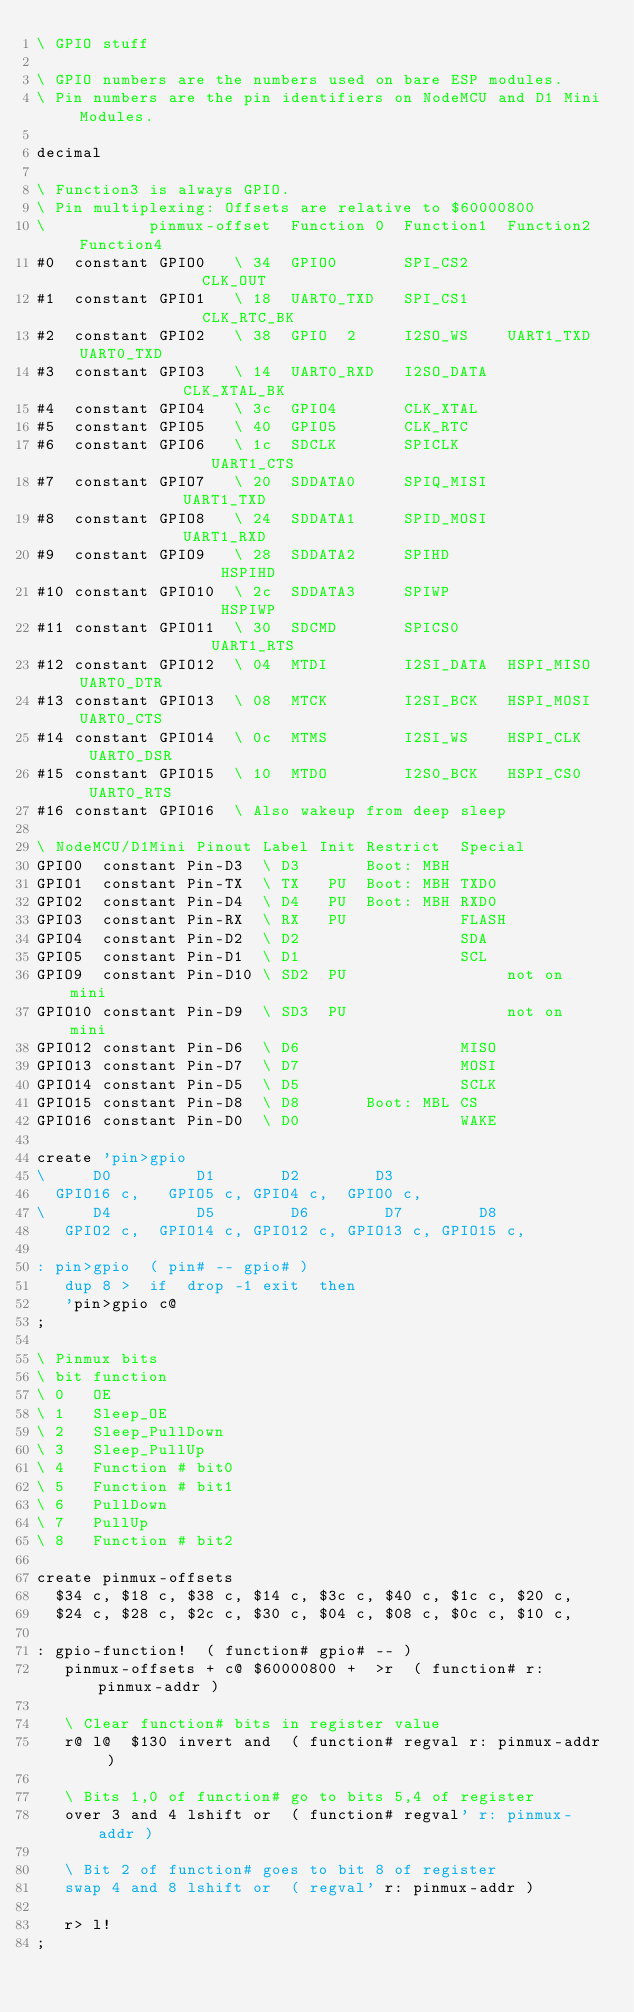<code> <loc_0><loc_0><loc_500><loc_500><_Forth_>\ GPIO stuff

\ GPIO numbers are the numbers used on bare ESP modules.
\ Pin numbers are the pin identifiers on NodeMCU and D1 Mini Modules.

decimal

\ Function3 is always GPIO.
\ Pin multiplexing: Offsets are relative to $60000800
\           pinmux-offset  Function 0  Function1  Function2  Function4
#0  constant GPIO0   \ 34  GPIO0       SPI_CS2               CLK_OUT
#1  constant GPIO1   \ 18  UART0_TXD   SPI_CS1               CLK_RTC_BK
#2  constant GPIO2   \ 38  GPIO  2     I2SO_WS    UART1_TXD  UART0_TXD
#3  constant GPIO3   \ 14  UART0_RXD   I2SO_DATA             CLK_XTAL_BK
#4  constant GPIO4   \ 3c  GPIO4       CLK_XTAL
#5  constant GPIO5   \ 40  GPIO5       CLK_RTC
#6  constant GPIO6   \ 1c  SDCLK       SPICLK                UART1_CTS
#7  constant GPIO7   \ 20  SDDATA0     SPIQ_MISI             UART1_TXD
#8  constant GPIO8   \ 24  SDDATA1     SPID_MOSI             UART1_RXD
#9  constant GPIO9   \ 28  SDDATA2     SPIHD                 HSPIHD
#10 constant GPIO10  \ 2c  SDDATA3     SPIWP                 HSPIWP
#11 constant GPIO11  \ 30  SDCMD       SPICS0                UART1_RTS
#12 constant GPIO12  \ 04  MTDI        I2SI_DATA  HSPI_MISO  UART0_DTR
#13 constant GPIO13  \ 08  MTCK        I2SI_BCK   HSPI_MOSI  UART0_CTS
#14 constant GPIO14  \ 0c  MTMS        I2SI_WS    HSPI_CLK   UART0_DSR
#15 constant GPIO15  \ 10  MTDO        I2S0_BCK   HSPI_CS0   UART0_RTS
#16 constant GPIO16  \ Also wakeup from deep sleep

\ NodeMCU/D1Mini Pinout Label Init Restrict  Special
GPIO0  constant Pin-D3  \ D3       Boot: MBH
GPIO1  constant Pin-TX  \ TX   PU  Boot: MBH TXD0
GPIO2  constant Pin-D4  \ D4   PU  Boot: MBH RXD0
GPIO3  constant Pin-RX  \ RX   PU            FLASH
GPIO4  constant Pin-D2  \ D2                 SDA
GPIO5  constant Pin-D1  \ D1                 SCL
GPIO9  constant Pin-D10 \ SD2  PU                 not on mini
GPIO10 constant Pin-D9  \ SD3  PU                 not on mini
GPIO12 constant Pin-D6  \ D6                 MISO
GPIO13 constant Pin-D7  \ D7                 MOSI
GPIO14 constant Pin-D5  \ D5                 SCLK
GPIO15 constant Pin-D8  \ D8       Boot: MBL CS
GPIO16 constant Pin-D0  \ D0                 WAKE

create 'pin>gpio
\     D0         D1       D2        D3   
  GPIO16 c,   GPIO5 c, GPIO4 c,  GPIO0 c,
\     D4         D5        D6        D7        D8      
   GPIO2 c,  GPIO14 c, GPIO12 c, GPIO13 c, GPIO15 c,

: pin>gpio  ( pin# -- gpio# )
   dup 8 >  if  drop -1 exit  then
   'pin>gpio c@
;

\ Pinmux bits
\ bit function
\ 0   OE
\ 1   Sleep_OE
\ 2   Sleep_PullDown
\ 3   Sleep_PullUp
\ 4   Function # bit0
\ 5   Function # bit1
\ 6   PullDown
\ 7   PullUp
\ 8   Function # bit2

create pinmux-offsets
  $34 c, $18 c, $38 c, $14 c, $3c c, $40 c, $1c c, $20 c,
  $24 c, $28 c, $2c c, $30 c, $04 c, $08 c, $0c c, $10 c,

: gpio-function!  ( function# gpio# -- )
   pinmux-offsets + c@ $60000800 +  >r  ( function# r: pinmux-addr )

   \ Clear function# bits in register value
   r@ l@  $130 invert and  ( function# regval r: pinmux-addr )

   \ Bits 1,0 of function# go to bits 5,4 of register
   over 3 and 4 lshift or  ( function# regval' r: pinmux-addr )

   \ Bit 2 of function# goes to bit 8 of register
   swap 4 and 8 lshift or  ( regval' r: pinmux-addr )

   r> l!
;
</code> 